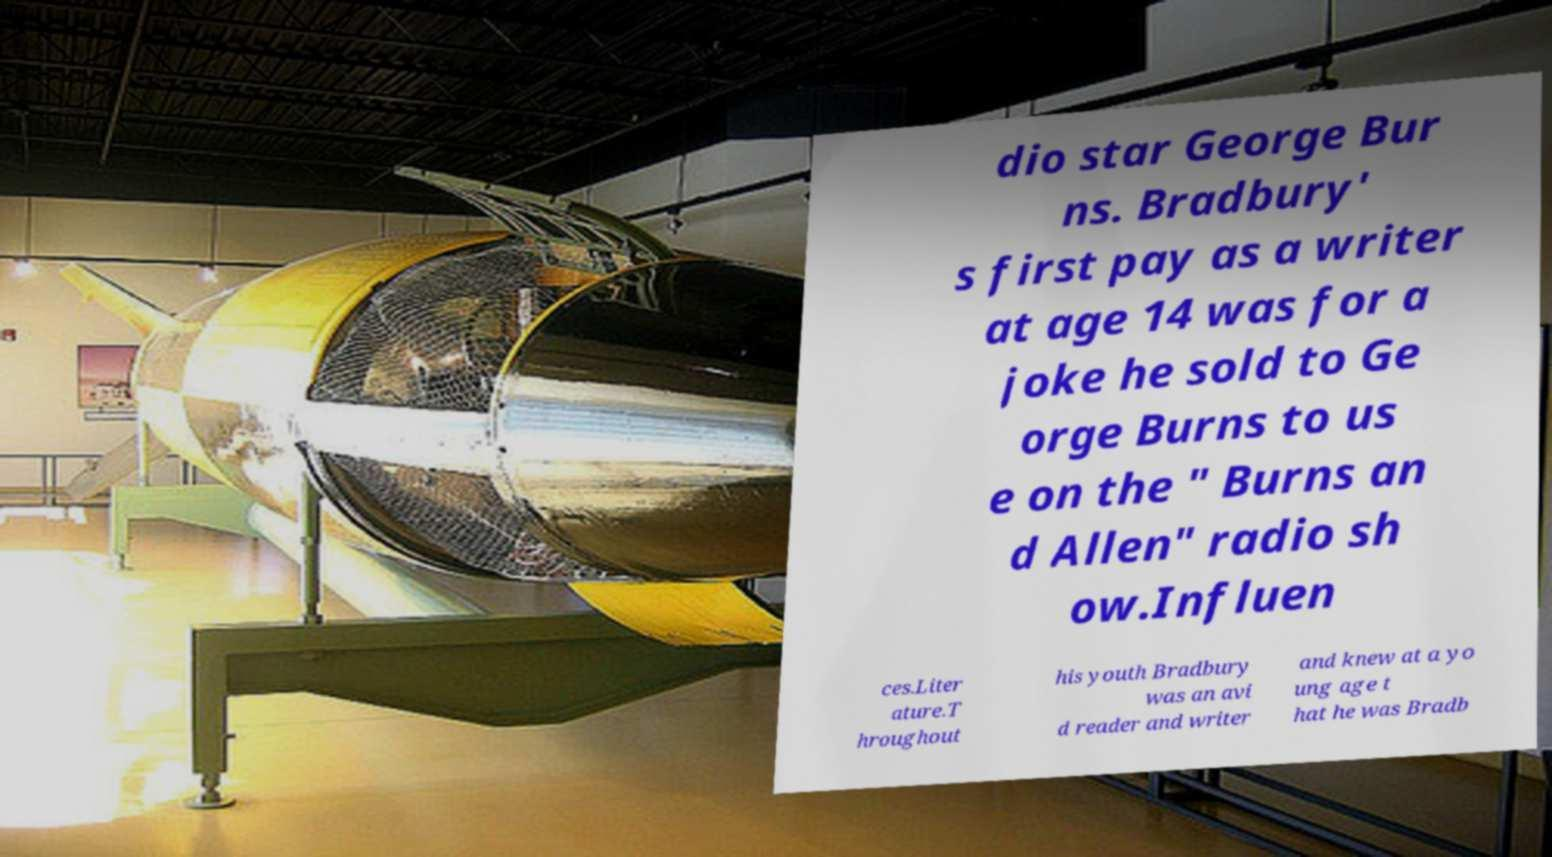There's text embedded in this image that I need extracted. Can you transcribe it verbatim? dio star George Bur ns. Bradbury' s first pay as a writer at age 14 was for a joke he sold to Ge orge Burns to us e on the " Burns an d Allen" radio sh ow.Influen ces.Liter ature.T hroughout his youth Bradbury was an avi d reader and writer and knew at a yo ung age t hat he was Bradb 